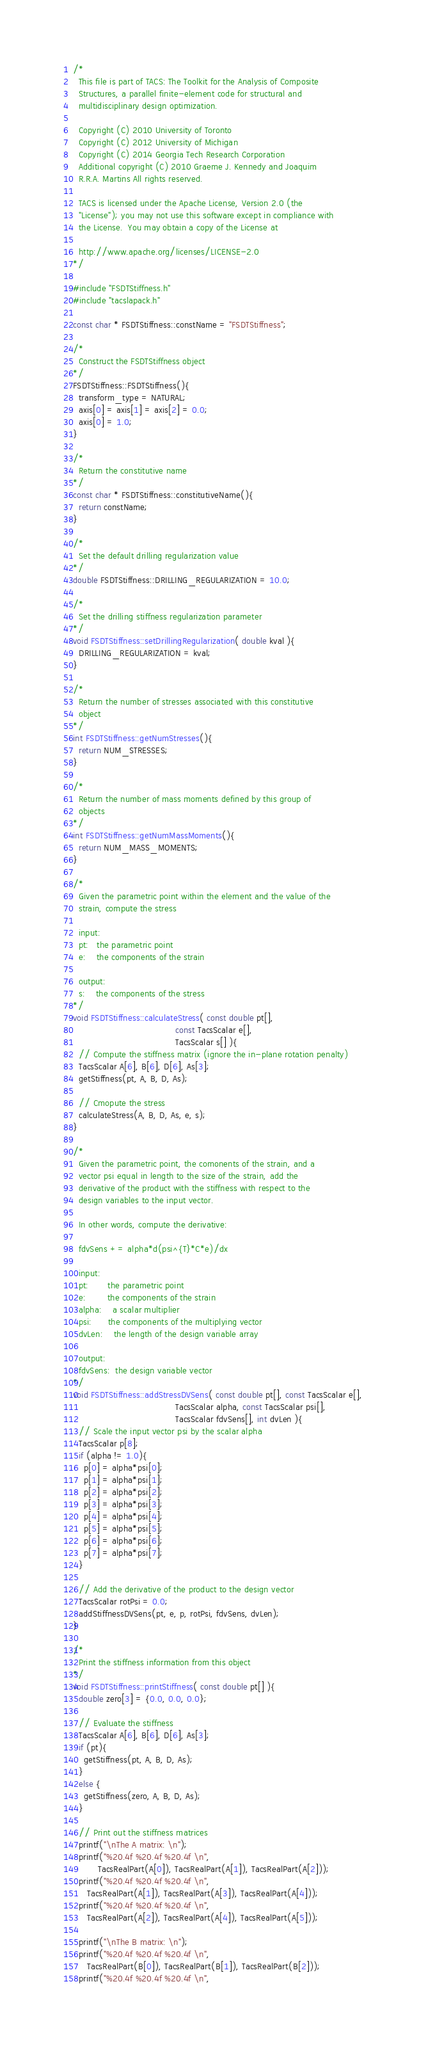<code> <loc_0><loc_0><loc_500><loc_500><_C++_>/*
  This file is part of TACS: The Toolkit for the Analysis of Composite
  Structures, a parallel finite-element code for structural and
  multidisciplinary design optimization.

  Copyright (C) 2010 University of Toronto
  Copyright (C) 2012 University of Michigan
  Copyright (C) 2014 Georgia Tech Research Corporation
  Additional copyright (C) 2010 Graeme J. Kennedy and Joaquim
  R.R.A. Martins All rights reserved.

  TACS is licensed under the Apache License, Version 2.0 (the
  "License"); you may not use this software except in compliance with
  the License.  You may obtain a copy of the License at
  
  http://www.apache.org/licenses/LICENSE-2.0 
*/

#include "FSDTStiffness.h"
#include "tacslapack.h"

const char * FSDTStiffness::constName = "FSDTStiffness";

/*
  Construct the FSDTStiffness object
*/
FSDTStiffness::FSDTStiffness(){
  transform_type = NATURAL;
  axis[0] = axis[1] = axis[2] = 0.0;
  axis[0] = 1.0;
}

/*
  Return the constitutive name
*/
const char * FSDTStiffness::constitutiveName(){ 
  return constName; 
}

/*
  Set the default drilling regularization value
*/
double FSDTStiffness::DRILLING_REGULARIZATION = 10.0;

/*
  Set the drilling stiffness regularization parameter
*/ 
void FSDTStiffness::setDrillingRegularization( double kval ){
  DRILLING_REGULARIZATION = kval;
}

/*
  Return the number of stresses associated with this constitutive
  object 
*/
int FSDTStiffness::getNumStresses(){ 
  return NUM_STRESSES; 
}

/*
  Return the number of mass moments defined by this group of
  objects
*/
int FSDTStiffness::getNumMassMoments(){
  return NUM_MASS_MOMENTS;
}

/*
  Given the parametric point within the element and the value of the 
  strain, compute the stress

  input:
  pt:   the parametric point
  e:    the components of the strain

  output:
  s:    the components of the stress
*/
void FSDTStiffness::calculateStress( const double pt[],
                                     const TacsScalar e[],
                                     TacsScalar s[] ){
  // Compute the stiffness matrix (ignore the in-plane rotation penalty)
  TacsScalar A[6], B[6], D[6], As[3];
  getStiffness(pt, A, B, D, As);

  // Cmopute the stress
  calculateStress(A, B, D, As, e, s);
}

/*
  Given the parametric point, the comonents of the strain, and a
  vector psi equal in length to the size of the strain, add the
  derivative of the product with the stiffness with respect to the
  design variables to the input vector.

  In other words, compute the derivative:

  fdvSens += alpha*d(psi^{T}*C*e)/dx

  input:
  pt:       the parametric point
  e:        the components of the strain
  alpha:    a scalar multiplier
  psi:      the components of the multiplying vector
  dvLen:    the length of the design variable array

  output:
  fdvSens:  the design variable vector
*/
void FSDTStiffness::addStressDVSens( const double pt[], const TacsScalar e[],
                                     TacsScalar alpha, const TacsScalar psi[], 
                                     TacsScalar fdvSens[], int dvLen ){
  // Scale the input vector psi by the scalar alpha
  TacsScalar p[8];
  if (alpha != 1.0){
    p[0] = alpha*psi[0];
    p[1] = alpha*psi[1];
    p[2] = alpha*psi[2];
    p[3] = alpha*psi[3];
    p[4] = alpha*psi[4];
    p[5] = alpha*psi[5];
    p[6] = alpha*psi[6];
    p[7] = alpha*psi[7];
  }

  // Add the derivative of the product to the design vector
  TacsScalar rotPsi = 0.0;
  addStiffnessDVSens(pt, e, p, rotPsi, fdvSens, dvLen);
}

/*
  Print the stiffness information from this object
*/
void FSDTStiffness::printStiffness( const double pt[] ){
  double zero[3] = {0.0, 0.0, 0.0};

  // Evaluate the stiffness
  TacsScalar A[6], B[6], D[6], As[3];
  if (pt){ 
    getStiffness(pt, A, B, D, As);
  }
  else {
    getStiffness(zero, A, B, D, As);
  }

  // Print out the stiffness matrices
  printf("\nThe A matrix: \n");
  printf("%20.4f %20.4f %20.4f \n", 
         TacsRealPart(A[0]), TacsRealPart(A[1]), TacsRealPart(A[2]));
  printf("%20.4f %20.4f %20.4f \n", 
	 TacsRealPart(A[1]), TacsRealPart(A[3]), TacsRealPart(A[4]));
  printf("%20.4f %20.4f %20.4f \n", 
	 TacsRealPart(A[2]), TacsRealPart(A[4]), TacsRealPart(A[5]));

  printf("\nThe B matrix: \n");
  printf("%20.4f %20.4f %20.4f \n", 
	 TacsRealPart(B[0]), TacsRealPart(B[1]), TacsRealPart(B[2]));
  printf("%20.4f %20.4f %20.4f \n", </code> 